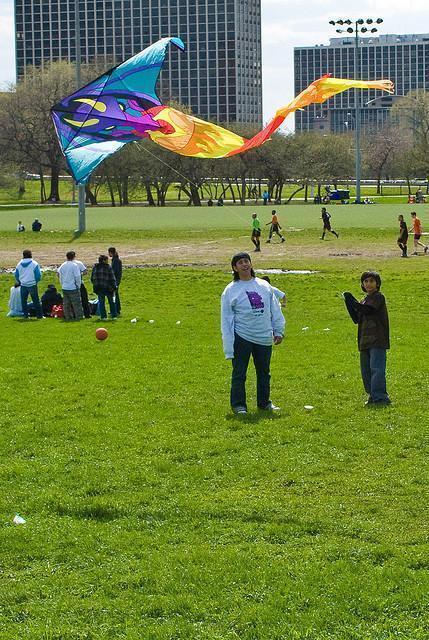The object in the air is in the shape of what animal?
From the following set of four choices, select the accurate answer to respond to the question.
Options: Panda, lizard, rabbit, stingray. Stingray. 